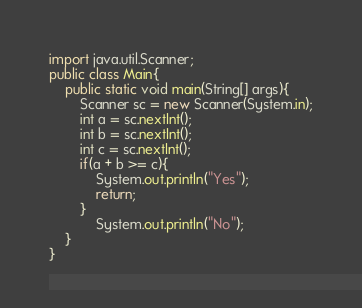<code> <loc_0><loc_0><loc_500><loc_500><_Java_>import java.util.Scanner;
public class Main{
    public static void main(String[] args){
        Scanner sc = new Scanner(System.in);
        int a = sc.nextInt();
        int b = sc.nextInt();
        int c = sc.nextInt();
        if(a + b >= c){
            System.out.println("Yes");
            return;
        }
            System.out.println("No");
    }
}
</code> 